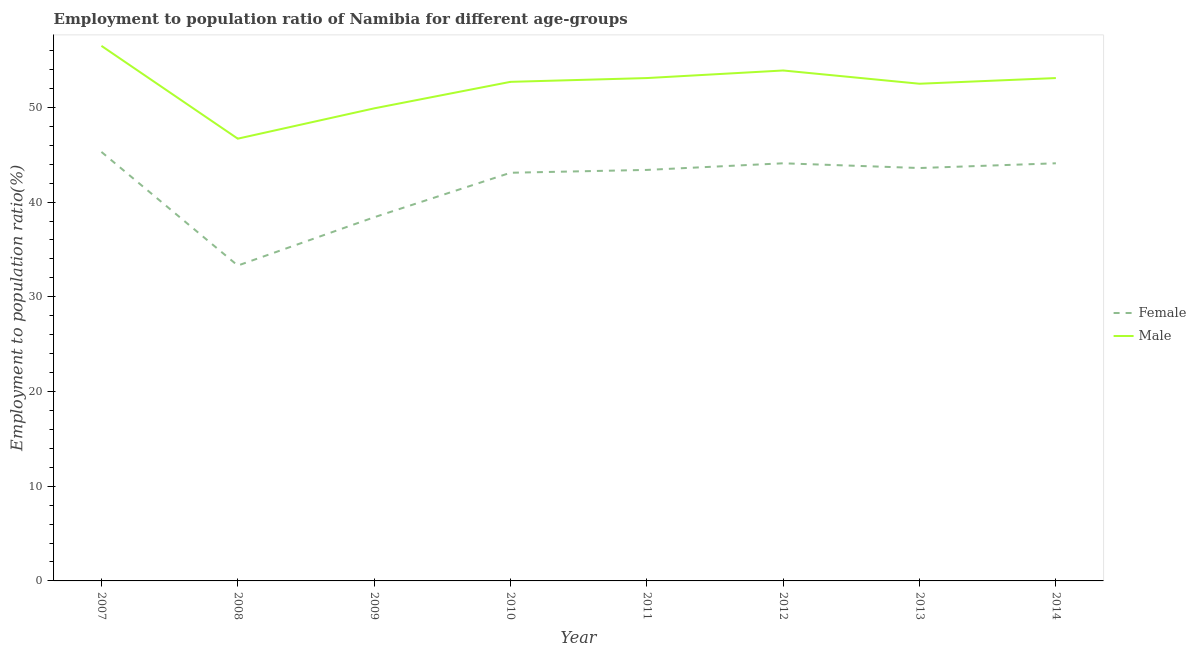How many different coloured lines are there?
Offer a terse response. 2. What is the employment to population ratio(male) in 2007?
Provide a succinct answer. 56.5. Across all years, what is the maximum employment to population ratio(male)?
Provide a short and direct response. 56.5. Across all years, what is the minimum employment to population ratio(male)?
Offer a terse response. 46.7. In which year was the employment to population ratio(male) minimum?
Your answer should be very brief. 2008. What is the total employment to population ratio(male) in the graph?
Make the answer very short. 418.4. What is the difference between the employment to population ratio(female) in 2007 and that in 2013?
Offer a very short reply. 1.7. What is the difference between the employment to population ratio(female) in 2011 and the employment to population ratio(male) in 2008?
Make the answer very short. -3.3. What is the average employment to population ratio(female) per year?
Ensure brevity in your answer.  41.91. In the year 2012, what is the difference between the employment to population ratio(male) and employment to population ratio(female)?
Your response must be concise. 9.8. What is the ratio of the employment to population ratio(male) in 2007 to that in 2014?
Provide a succinct answer. 1.06. Is the difference between the employment to population ratio(female) in 2013 and 2014 greater than the difference between the employment to population ratio(male) in 2013 and 2014?
Provide a succinct answer. Yes. What is the difference between the highest and the second highest employment to population ratio(female)?
Offer a terse response. 1.2. What is the difference between the highest and the lowest employment to population ratio(male)?
Provide a short and direct response. 9.8. In how many years, is the employment to population ratio(male) greater than the average employment to population ratio(male) taken over all years?
Offer a terse response. 6. Is the sum of the employment to population ratio(male) in 2007 and 2014 greater than the maximum employment to population ratio(female) across all years?
Make the answer very short. Yes. Is the employment to population ratio(male) strictly less than the employment to population ratio(female) over the years?
Ensure brevity in your answer.  No. Does the graph contain grids?
Offer a terse response. No. How many legend labels are there?
Keep it short and to the point. 2. How are the legend labels stacked?
Keep it short and to the point. Vertical. What is the title of the graph?
Keep it short and to the point. Employment to population ratio of Namibia for different age-groups. Does "Infant" appear as one of the legend labels in the graph?
Provide a short and direct response. No. What is the Employment to population ratio(%) in Female in 2007?
Keep it short and to the point. 45.3. What is the Employment to population ratio(%) in Male in 2007?
Give a very brief answer. 56.5. What is the Employment to population ratio(%) of Female in 2008?
Give a very brief answer. 33.3. What is the Employment to population ratio(%) in Male in 2008?
Your answer should be very brief. 46.7. What is the Employment to population ratio(%) in Female in 2009?
Ensure brevity in your answer.  38.4. What is the Employment to population ratio(%) of Male in 2009?
Your response must be concise. 49.9. What is the Employment to population ratio(%) of Female in 2010?
Provide a succinct answer. 43.1. What is the Employment to population ratio(%) of Male in 2010?
Offer a terse response. 52.7. What is the Employment to population ratio(%) of Female in 2011?
Provide a short and direct response. 43.4. What is the Employment to population ratio(%) of Male in 2011?
Make the answer very short. 53.1. What is the Employment to population ratio(%) in Female in 2012?
Your answer should be very brief. 44.1. What is the Employment to population ratio(%) of Male in 2012?
Give a very brief answer. 53.9. What is the Employment to population ratio(%) of Female in 2013?
Ensure brevity in your answer.  43.6. What is the Employment to population ratio(%) of Male in 2013?
Provide a succinct answer. 52.5. What is the Employment to population ratio(%) in Female in 2014?
Keep it short and to the point. 44.1. What is the Employment to population ratio(%) of Male in 2014?
Keep it short and to the point. 53.1. Across all years, what is the maximum Employment to population ratio(%) in Female?
Your answer should be compact. 45.3. Across all years, what is the maximum Employment to population ratio(%) in Male?
Your response must be concise. 56.5. Across all years, what is the minimum Employment to population ratio(%) in Female?
Provide a succinct answer. 33.3. Across all years, what is the minimum Employment to population ratio(%) in Male?
Your answer should be compact. 46.7. What is the total Employment to population ratio(%) in Female in the graph?
Provide a succinct answer. 335.3. What is the total Employment to population ratio(%) in Male in the graph?
Give a very brief answer. 418.4. What is the difference between the Employment to population ratio(%) in Female in 2007 and that in 2009?
Offer a very short reply. 6.9. What is the difference between the Employment to population ratio(%) of Male in 2007 and that in 2009?
Your answer should be very brief. 6.6. What is the difference between the Employment to population ratio(%) of Female in 2007 and that in 2010?
Your response must be concise. 2.2. What is the difference between the Employment to population ratio(%) in Male in 2007 and that in 2010?
Keep it short and to the point. 3.8. What is the difference between the Employment to population ratio(%) of Male in 2007 and that in 2011?
Ensure brevity in your answer.  3.4. What is the difference between the Employment to population ratio(%) of Female in 2007 and that in 2013?
Offer a very short reply. 1.7. What is the difference between the Employment to population ratio(%) of Male in 2007 and that in 2013?
Make the answer very short. 4. What is the difference between the Employment to population ratio(%) in Female in 2007 and that in 2014?
Provide a succinct answer. 1.2. What is the difference between the Employment to population ratio(%) of Male in 2008 and that in 2009?
Make the answer very short. -3.2. What is the difference between the Employment to population ratio(%) in Female in 2008 and that in 2010?
Offer a terse response. -9.8. What is the difference between the Employment to population ratio(%) in Female in 2008 and that in 2011?
Provide a succinct answer. -10.1. What is the difference between the Employment to population ratio(%) in Male in 2008 and that in 2011?
Give a very brief answer. -6.4. What is the difference between the Employment to population ratio(%) of Female in 2008 and that in 2012?
Make the answer very short. -10.8. What is the difference between the Employment to population ratio(%) of Female in 2008 and that in 2014?
Provide a succinct answer. -10.8. What is the difference between the Employment to population ratio(%) in Male in 2009 and that in 2010?
Your response must be concise. -2.8. What is the difference between the Employment to population ratio(%) of Male in 2009 and that in 2011?
Offer a very short reply. -3.2. What is the difference between the Employment to population ratio(%) of Female in 2009 and that in 2012?
Your response must be concise. -5.7. What is the difference between the Employment to population ratio(%) in Female in 2009 and that in 2014?
Your answer should be compact. -5.7. What is the difference between the Employment to population ratio(%) in Male in 2009 and that in 2014?
Make the answer very short. -3.2. What is the difference between the Employment to population ratio(%) of Female in 2010 and that in 2011?
Make the answer very short. -0.3. What is the difference between the Employment to population ratio(%) of Female in 2010 and that in 2013?
Your answer should be very brief. -0.5. What is the difference between the Employment to population ratio(%) in Female in 2010 and that in 2014?
Your answer should be very brief. -1. What is the difference between the Employment to population ratio(%) in Male in 2010 and that in 2014?
Give a very brief answer. -0.4. What is the difference between the Employment to population ratio(%) in Female in 2011 and that in 2012?
Your answer should be compact. -0.7. What is the difference between the Employment to population ratio(%) in Female in 2011 and that in 2013?
Keep it short and to the point. -0.2. What is the difference between the Employment to population ratio(%) in Female in 2011 and that in 2014?
Give a very brief answer. -0.7. What is the difference between the Employment to population ratio(%) in Male in 2011 and that in 2014?
Ensure brevity in your answer.  0. What is the difference between the Employment to population ratio(%) of Male in 2012 and that in 2013?
Offer a terse response. 1.4. What is the difference between the Employment to population ratio(%) of Female in 2012 and that in 2014?
Provide a succinct answer. 0. What is the difference between the Employment to population ratio(%) in Male in 2012 and that in 2014?
Your response must be concise. 0.8. What is the difference between the Employment to population ratio(%) in Female in 2013 and that in 2014?
Make the answer very short. -0.5. What is the difference between the Employment to population ratio(%) in Female in 2007 and the Employment to population ratio(%) in Male in 2008?
Provide a succinct answer. -1.4. What is the difference between the Employment to population ratio(%) in Female in 2007 and the Employment to population ratio(%) in Male in 2009?
Give a very brief answer. -4.6. What is the difference between the Employment to population ratio(%) of Female in 2007 and the Employment to population ratio(%) of Male in 2010?
Your answer should be very brief. -7.4. What is the difference between the Employment to population ratio(%) in Female in 2007 and the Employment to population ratio(%) in Male in 2011?
Keep it short and to the point. -7.8. What is the difference between the Employment to population ratio(%) of Female in 2007 and the Employment to population ratio(%) of Male in 2012?
Offer a very short reply. -8.6. What is the difference between the Employment to population ratio(%) in Female in 2008 and the Employment to population ratio(%) in Male in 2009?
Your answer should be very brief. -16.6. What is the difference between the Employment to population ratio(%) in Female in 2008 and the Employment to population ratio(%) in Male in 2010?
Your response must be concise. -19.4. What is the difference between the Employment to population ratio(%) of Female in 2008 and the Employment to population ratio(%) of Male in 2011?
Ensure brevity in your answer.  -19.8. What is the difference between the Employment to population ratio(%) in Female in 2008 and the Employment to population ratio(%) in Male in 2012?
Make the answer very short. -20.6. What is the difference between the Employment to population ratio(%) of Female in 2008 and the Employment to population ratio(%) of Male in 2013?
Provide a succinct answer. -19.2. What is the difference between the Employment to population ratio(%) in Female in 2008 and the Employment to population ratio(%) in Male in 2014?
Make the answer very short. -19.8. What is the difference between the Employment to population ratio(%) of Female in 2009 and the Employment to population ratio(%) of Male in 2010?
Offer a very short reply. -14.3. What is the difference between the Employment to population ratio(%) in Female in 2009 and the Employment to population ratio(%) in Male in 2011?
Ensure brevity in your answer.  -14.7. What is the difference between the Employment to population ratio(%) of Female in 2009 and the Employment to population ratio(%) of Male in 2012?
Provide a short and direct response. -15.5. What is the difference between the Employment to population ratio(%) in Female in 2009 and the Employment to population ratio(%) in Male in 2013?
Make the answer very short. -14.1. What is the difference between the Employment to population ratio(%) of Female in 2009 and the Employment to population ratio(%) of Male in 2014?
Offer a very short reply. -14.7. What is the difference between the Employment to population ratio(%) of Female in 2010 and the Employment to population ratio(%) of Male in 2013?
Offer a very short reply. -9.4. What is the difference between the Employment to population ratio(%) in Female in 2012 and the Employment to population ratio(%) in Male in 2013?
Your answer should be very brief. -8.4. What is the difference between the Employment to population ratio(%) of Female in 2012 and the Employment to population ratio(%) of Male in 2014?
Offer a terse response. -9. What is the average Employment to population ratio(%) of Female per year?
Provide a succinct answer. 41.91. What is the average Employment to population ratio(%) in Male per year?
Ensure brevity in your answer.  52.3. In the year 2007, what is the difference between the Employment to population ratio(%) in Female and Employment to population ratio(%) in Male?
Your answer should be very brief. -11.2. In the year 2010, what is the difference between the Employment to population ratio(%) in Female and Employment to population ratio(%) in Male?
Offer a terse response. -9.6. In the year 2011, what is the difference between the Employment to population ratio(%) of Female and Employment to population ratio(%) of Male?
Make the answer very short. -9.7. In the year 2013, what is the difference between the Employment to population ratio(%) of Female and Employment to population ratio(%) of Male?
Your response must be concise. -8.9. In the year 2014, what is the difference between the Employment to population ratio(%) in Female and Employment to population ratio(%) in Male?
Provide a short and direct response. -9. What is the ratio of the Employment to population ratio(%) of Female in 2007 to that in 2008?
Give a very brief answer. 1.36. What is the ratio of the Employment to population ratio(%) of Male in 2007 to that in 2008?
Your answer should be very brief. 1.21. What is the ratio of the Employment to population ratio(%) in Female in 2007 to that in 2009?
Provide a succinct answer. 1.18. What is the ratio of the Employment to population ratio(%) of Male in 2007 to that in 2009?
Give a very brief answer. 1.13. What is the ratio of the Employment to population ratio(%) in Female in 2007 to that in 2010?
Give a very brief answer. 1.05. What is the ratio of the Employment to population ratio(%) of Male in 2007 to that in 2010?
Your response must be concise. 1.07. What is the ratio of the Employment to population ratio(%) of Female in 2007 to that in 2011?
Provide a short and direct response. 1.04. What is the ratio of the Employment to population ratio(%) in Male in 2007 to that in 2011?
Your answer should be compact. 1.06. What is the ratio of the Employment to population ratio(%) in Female in 2007 to that in 2012?
Provide a short and direct response. 1.03. What is the ratio of the Employment to population ratio(%) in Male in 2007 to that in 2012?
Ensure brevity in your answer.  1.05. What is the ratio of the Employment to population ratio(%) in Female in 2007 to that in 2013?
Make the answer very short. 1.04. What is the ratio of the Employment to population ratio(%) of Male in 2007 to that in 2013?
Give a very brief answer. 1.08. What is the ratio of the Employment to population ratio(%) in Female in 2007 to that in 2014?
Give a very brief answer. 1.03. What is the ratio of the Employment to population ratio(%) in Male in 2007 to that in 2014?
Provide a short and direct response. 1.06. What is the ratio of the Employment to population ratio(%) in Female in 2008 to that in 2009?
Provide a short and direct response. 0.87. What is the ratio of the Employment to population ratio(%) of Male in 2008 to that in 2009?
Make the answer very short. 0.94. What is the ratio of the Employment to population ratio(%) of Female in 2008 to that in 2010?
Offer a terse response. 0.77. What is the ratio of the Employment to population ratio(%) in Male in 2008 to that in 2010?
Provide a short and direct response. 0.89. What is the ratio of the Employment to population ratio(%) of Female in 2008 to that in 2011?
Keep it short and to the point. 0.77. What is the ratio of the Employment to population ratio(%) in Male in 2008 to that in 2011?
Offer a very short reply. 0.88. What is the ratio of the Employment to population ratio(%) of Female in 2008 to that in 2012?
Make the answer very short. 0.76. What is the ratio of the Employment to population ratio(%) in Male in 2008 to that in 2012?
Give a very brief answer. 0.87. What is the ratio of the Employment to population ratio(%) in Female in 2008 to that in 2013?
Ensure brevity in your answer.  0.76. What is the ratio of the Employment to population ratio(%) in Male in 2008 to that in 2013?
Make the answer very short. 0.89. What is the ratio of the Employment to population ratio(%) of Female in 2008 to that in 2014?
Make the answer very short. 0.76. What is the ratio of the Employment to population ratio(%) of Male in 2008 to that in 2014?
Make the answer very short. 0.88. What is the ratio of the Employment to population ratio(%) in Female in 2009 to that in 2010?
Keep it short and to the point. 0.89. What is the ratio of the Employment to population ratio(%) of Male in 2009 to that in 2010?
Make the answer very short. 0.95. What is the ratio of the Employment to population ratio(%) of Female in 2009 to that in 2011?
Your answer should be compact. 0.88. What is the ratio of the Employment to population ratio(%) in Male in 2009 to that in 2011?
Offer a very short reply. 0.94. What is the ratio of the Employment to population ratio(%) in Female in 2009 to that in 2012?
Keep it short and to the point. 0.87. What is the ratio of the Employment to population ratio(%) of Male in 2009 to that in 2012?
Your response must be concise. 0.93. What is the ratio of the Employment to population ratio(%) in Female in 2009 to that in 2013?
Keep it short and to the point. 0.88. What is the ratio of the Employment to population ratio(%) of Male in 2009 to that in 2013?
Keep it short and to the point. 0.95. What is the ratio of the Employment to population ratio(%) in Female in 2009 to that in 2014?
Offer a terse response. 0.87. What is the ratio of the Employment to population ratio(%) in Male in 2009 to that in 2014?
Offer a terse response. 0.94. What is the ratio of the Employment to population ratio(%) in Female in 2010 to that in 2011?
Offer a terse response. 0.99. What is the ratio of the Employment to population ratio(%) of Male in 2010 to that in 2011?
Your response must be concise. 0.99. What is the ratio of the Employment to population ratio(%) in Female in 2010 to that in 2012?
Provide a succinct answer. 0.98. What is the ratio of the Employment to population ratio(%) in Male in 2010 to that in 2012?
Provide a succinct answer. 0.98. What is the ratio of the Employment to population ratio(%) of Male in 2010 to that in 2013?
Provide a short and direct response. 1. What is the ratio of the Employment to population ratio(%) in Female in 2010 to that in 2014?
Ensure brevity in your answer.  0.98. What is the ratio of the Employment to population ratio(%) in Female in 2011 to that in 2012?
Offer a very short reply. 0.98. What is the ratio of the Employment to population ratio(%) in Male in 2011 to that in 2012?
Your answer should be very brief. 0.99. What is the ratio of the Employment to population ratio(%) of Female in 2011 to that in 2013?
Offer a terse response. 1. What is the ratio of the Employment to population ratio(%) of Male in 2011 to that in 2013?
Your answer should be very brief. 1.01. What is the ratio of the Employment to population ratio(%) in Female in 2011 to that in 2014?
Give a very brief answer. 0.98. What is the ratio of the Employment to population ratio(%) in Male in 2011 to that in 2014?
Your answer should be compact. 1. What is the ratio of the Employment to population ratio(%) of Female in 2012 to that in 2013?
Make the answer very short. 1.01. What is the ratio of the Employment to population ratio(%) in Male in 2012 to that in 2013?
Your answer should be very brief. 1.03. What is the ratio of the Employment to population ratio(%) in Male in 2012 to that in 2014?
Your answer should be compact. 1.02. What is the ratio of the Employment to population ratio(%) in Female in 2013 to that in 2014?
Keep it short and to the point. 0.99. What is the ratio of the Employment to population ratio(%) in Male in 2013 to that in 2014?
Your answer should be very brief. 0.99. What is the difference between the highest and the second highest Employment to population ratio(%) of Female?
Ensure brevity in your answer.  1.2. What is the difference between the highest and the lowest Employment to population ratio(%) in Female?
Offer a terse response. 12. What is the difference between the highest and the lowest Employment to population ratio(%) in Male?
Your answer should be very brief. 9.8. 